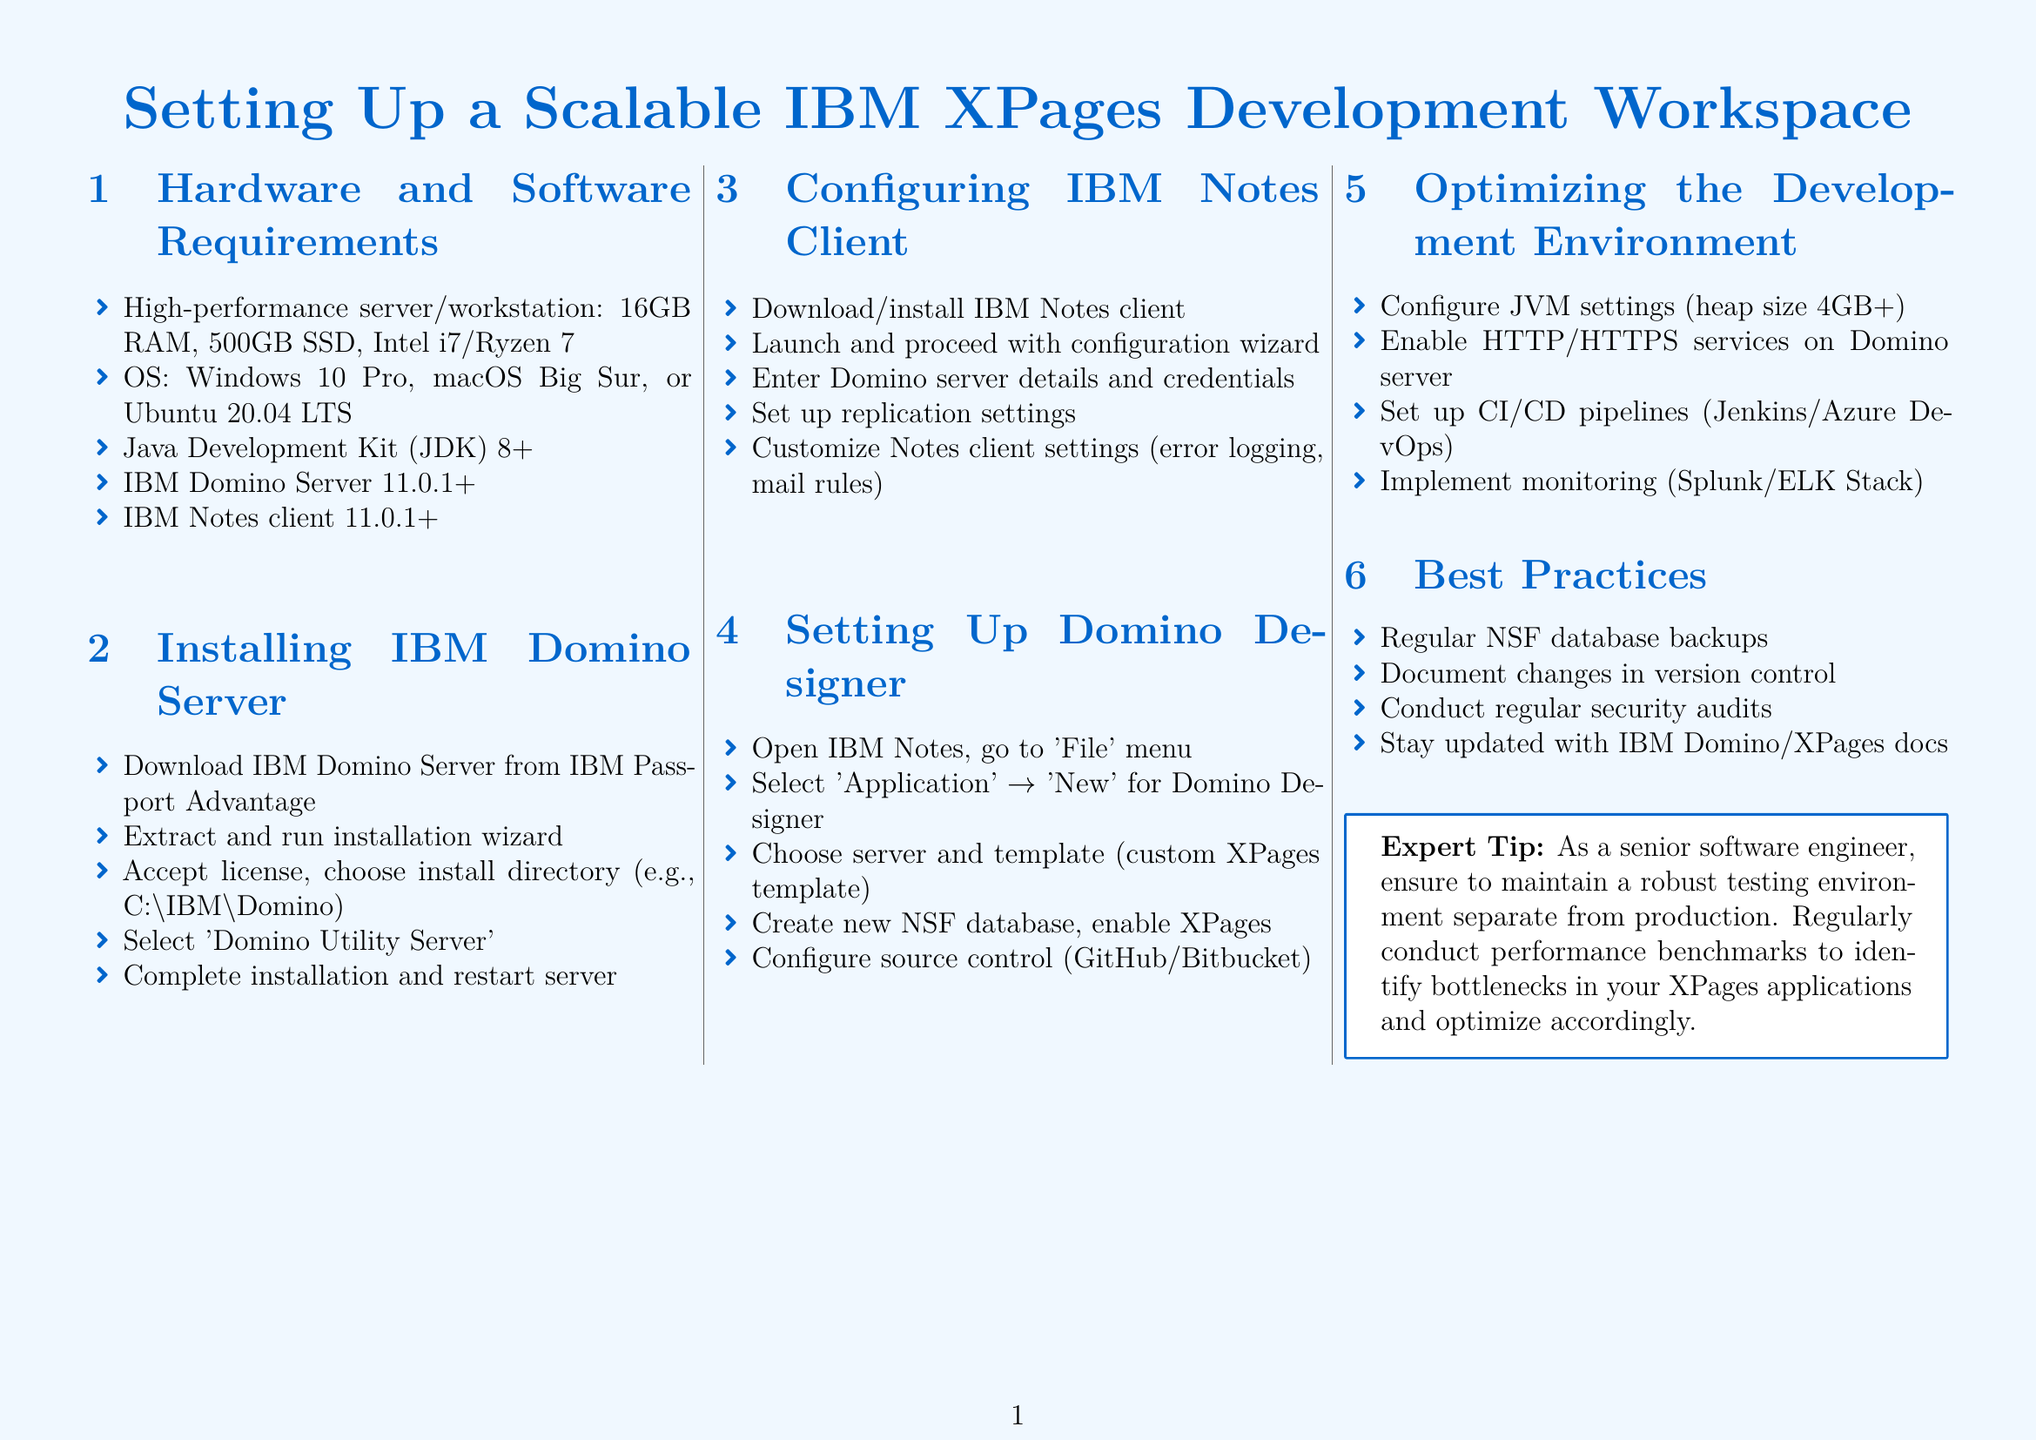What is the recommended RAM for the server? The document states that the hardware requirement is a high-performance server/workstation with 16GB RAM.
Answer: 16GB RAM What operating systems are mentioned? The document lists three operating systems suitable for the setup: Windows 10 Pro, macOS Big Sur, or Ubuntu 20.04 LTS.
Answer: Windows 10 Pro, macOS Big Sur, Ubuntu 20.04 LTS What version of IBM Domino Server is required? The document specifies that IBM Domino Server version 11.0.1 or higher is required.
Answer: 11.0.1+ How many steps are in the installation process for IBM Domino Server? The document outlines five steps in the installation process for IBM Domino Server.
Answer: Five What is the heap size configuration recommended for JVM settings? The document recommends configuring JVM settings to have a heap size of 4GB or more.
Answer: 4GB+ What should you do to ensure a robust testing environment? As suggested in the expert tip, maintaining a robust testing environment separate from production is important.
Answer: Separate from production What tool is suggested for monitoring? The document mentions implementing monitoring with either Splunk or ELK Stack.
Answer: Splunk/ELK Stack How many best practices are listed in the document? The document enumerates four best practices in the section provided.
Answer: Four Which source control systems are mentioned for configuration? The document indicates configuring source control with GitHub or Bitbucket.
Answer: GitHub/Bitbucket 